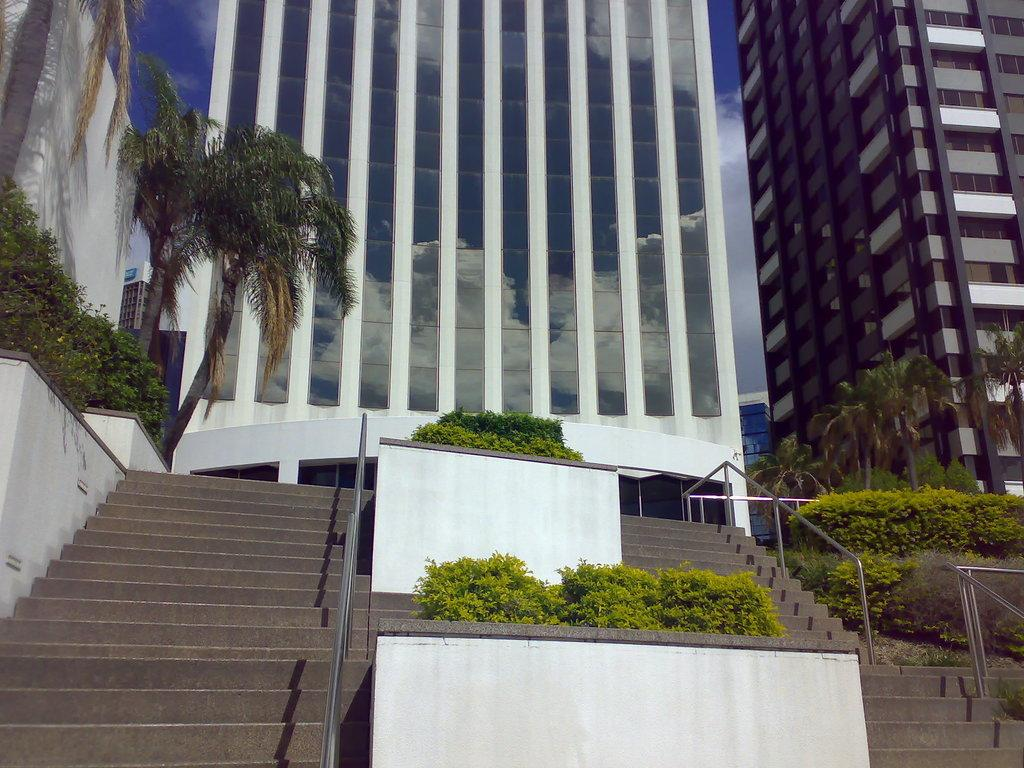What type of structures can be seen in the image? There are buildings in the image. What celestial objects are visible in the foreground of the image? There are stars and planets in the foreground of the image. What type of vegetation is on the left side of the image? There are trees on the left side of the image. What type of vegetation is on the right side of the image? There are trees on the right side of the image. What type of doctor is present in the image? There is no doctor present in the image. What day of the week is depicted in the image? The image does not depict a specific day of the week. 